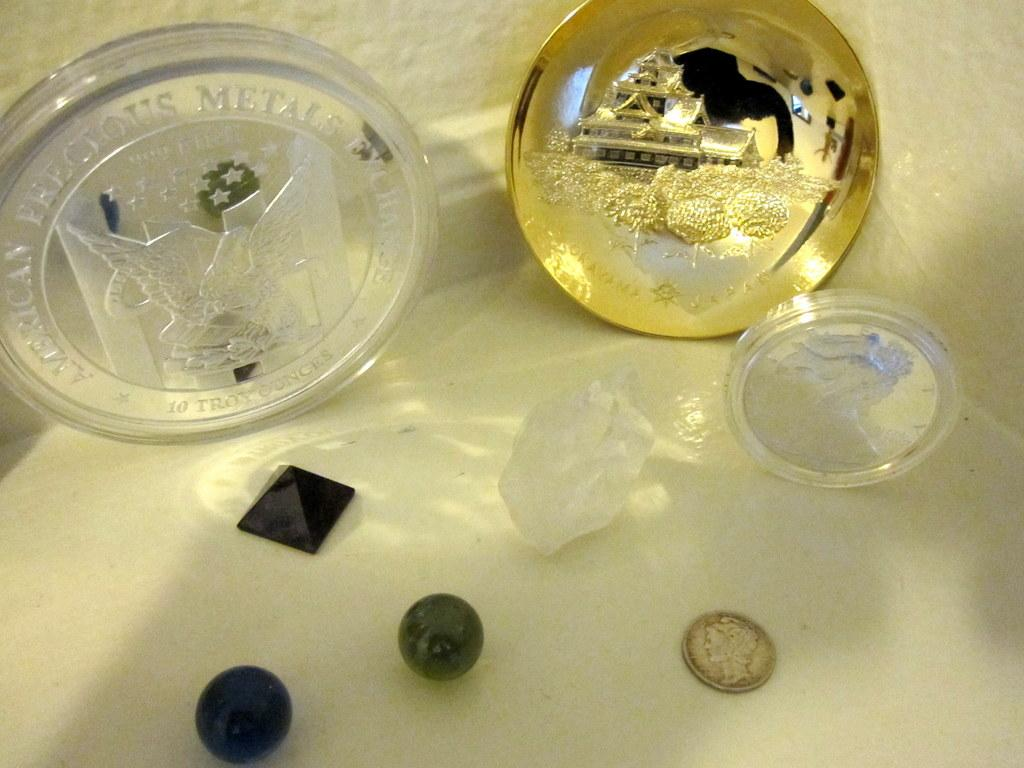<image>
Share a concise interpretation of the image provided. An American Precious Metals exchange plaque is shown with other trinquets. 